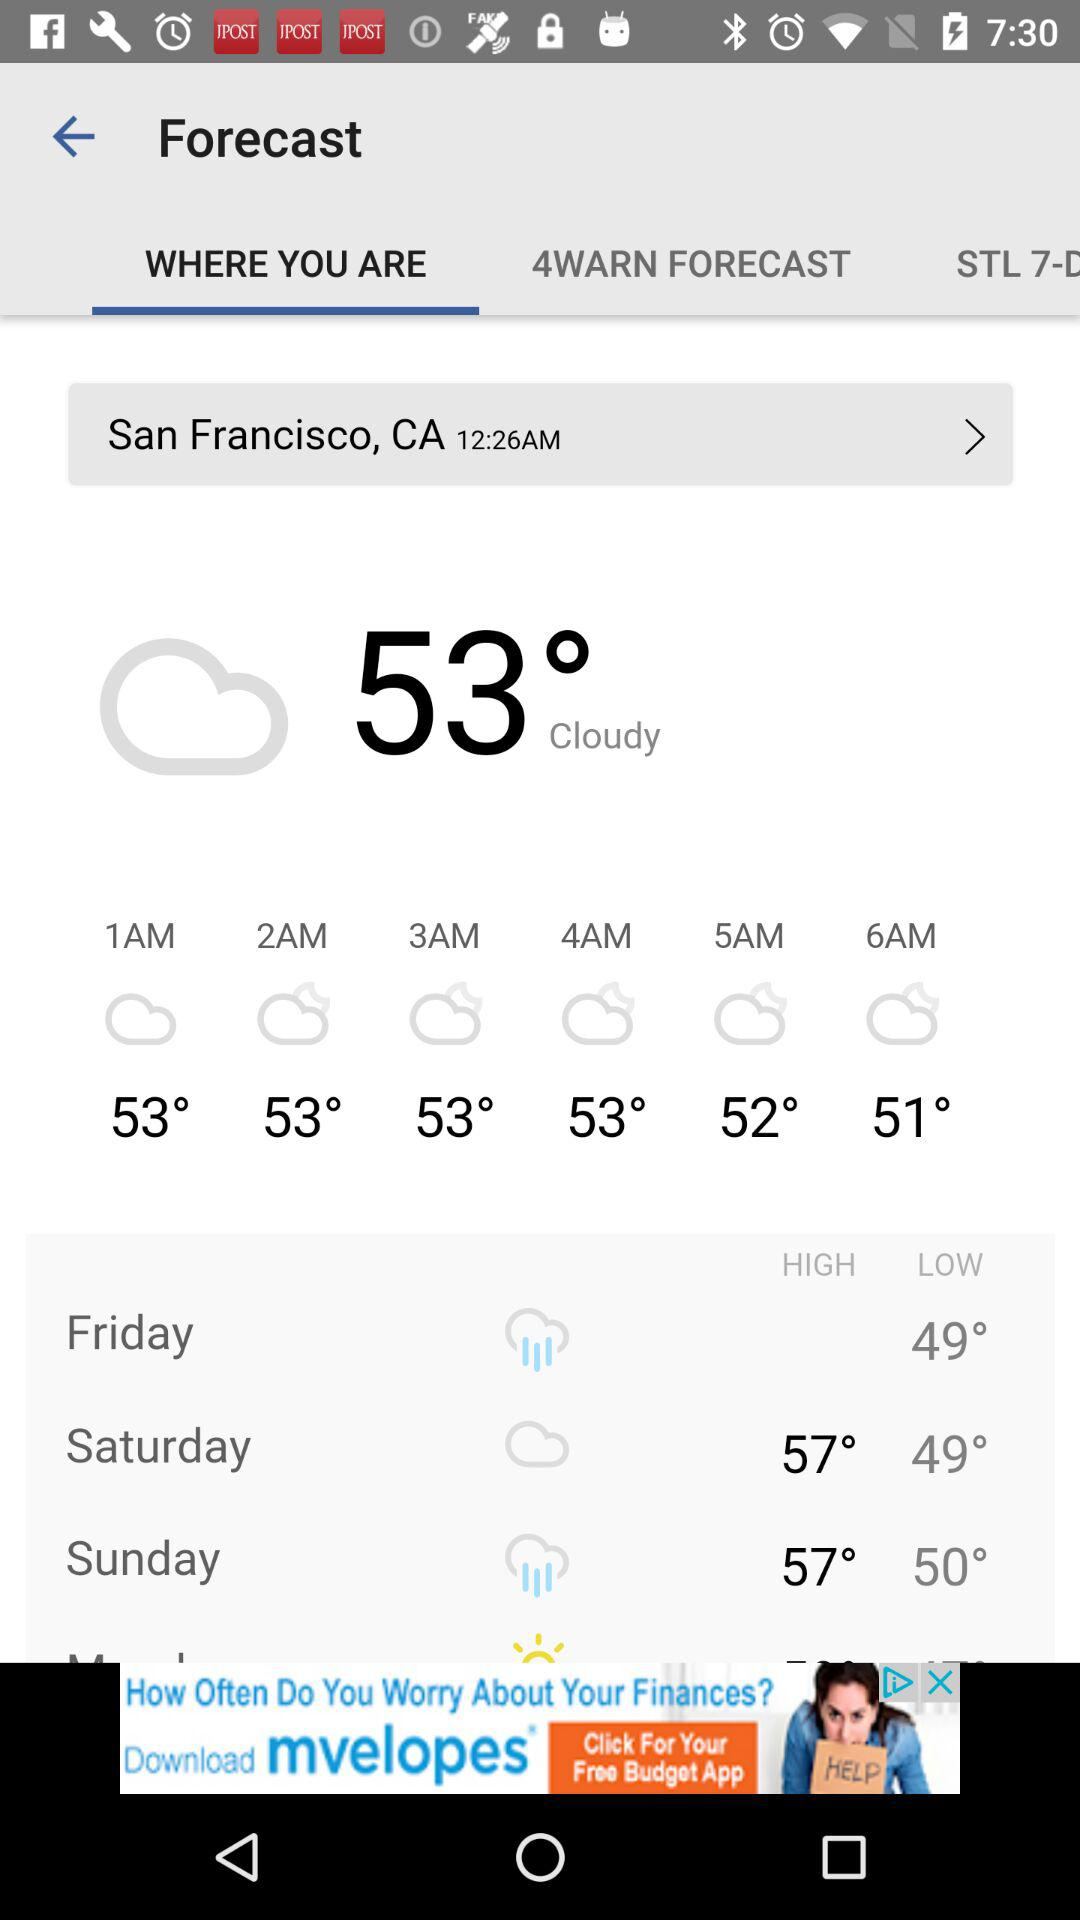How is the weather in San Francisco? The weather in San Francisco is cloudy. 